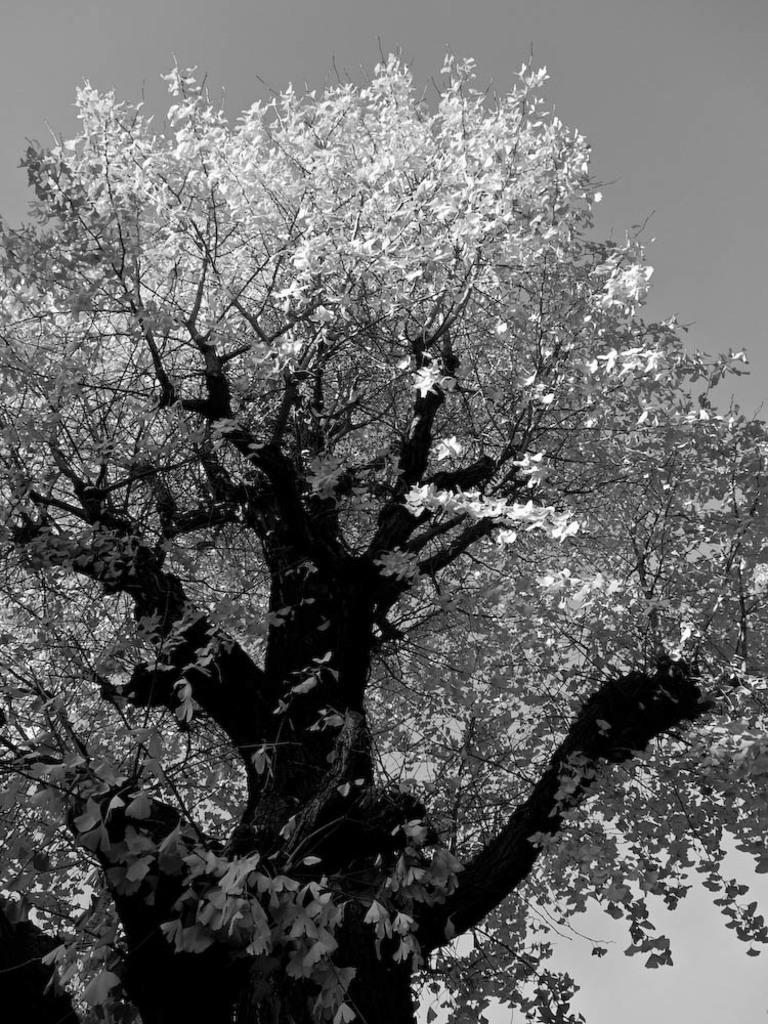What type of plant can be seen in the image? There is a tree in the image. What part of the natural environment is visible in the image? The sky is visible in the image. How is the image presented in terms of color? The image is in black and white mode. Can you see any tomatoes growing on the tree in the image? There are no tomatoes present in the image, as it only features a tree and the sky. 